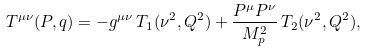<formula> <loc_0><loc_0><loc_500><loc_500>& T ^ { \mu \nu } ( P , q ) = - g ^ { \mu \nu } \, T _ { 1 } ( \nu ^ { 2 } , Q ^ { 2 } ) + \frac { P ^ { \mu } P ^ { \nu } } { M _ { p } ^ { 2 } } \, T _ { 2 } ( \nu ^ { 2 } , Q ^ { 2 } ) ,</formula> 